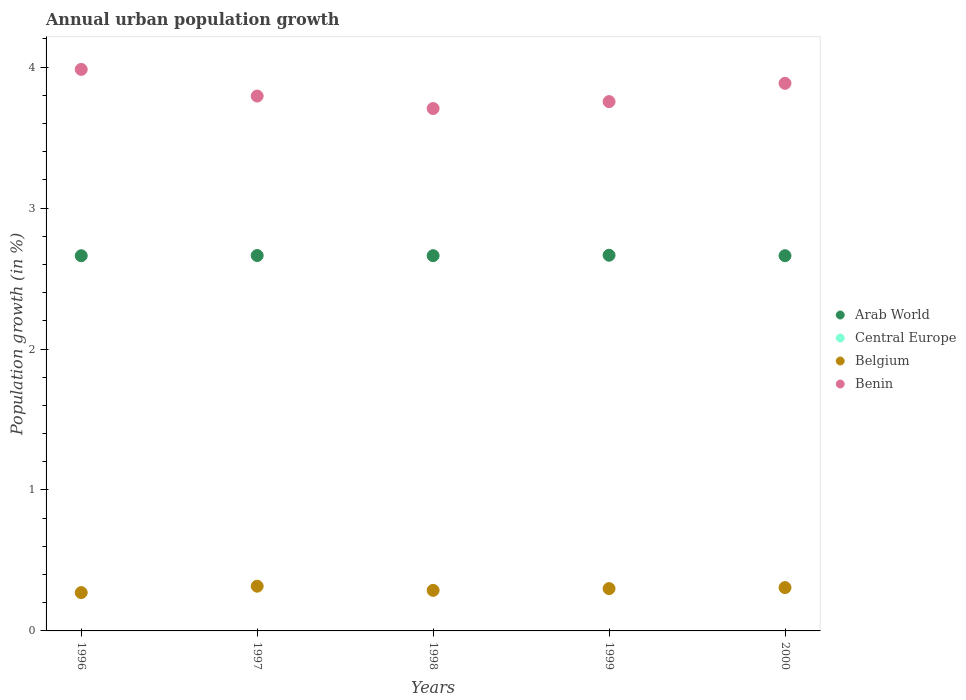Is the number of dotlines equal to the number of legend labels?
Your answer should be very brief. No. What is the percentage of urban population growth in Central Europe in 1999?
Offer a terse response. 0. Across all years, what is the maximum percentage of urban population growth in Arab World?
Your response must be concise. 2.67. What is the total percentage of urban population growth in Central Europe in the graph?
Keep it short and to the point. 0. What is the difference between the percentage of urban population growth in Benin in 1997 and that in 2000?
Give a very brief answer. -0.09. What is the difference between the percentage of urban population growth in Arab World in 1997 and the percentage of urban population growth in Belgium in 1996?
Ensure brevity in your answer.  2.39. In the year 1996, what is the difference between the percentage of urban population growth in Arab World and percentage of urban population growth in Benin?
Ensure brevity in your answer.  -1.32. In how many years, is the percentage of urban population growth in Central Europe greater than 2.8 %?
Keep it short and to the point. 0. What is the ratio of the percentage of urban population growth in Arab World in 1999 to that in 2000?
Your response must be concise. 1. Is the difference between the percentage of urban population growth in Arab World in 1996 and 1999 greater than the difference between the percentage of urban population growth in Benin in 1996 and 1999?
Offer a terse response. No. What is the difference between the highest and the second highest percentage of urban population growth in Benin?
Provide a short and direct response. 0.1. What is the difference between the highest and the lowest percentage of urban population growth in Arab World?
Make the answer very short. 0. In how many years, is the percentage of urban population growth in Arab World greater than the average percentage of urban population growth in Arab World taken over all years?
Give a very brief answer. 2. Is it the case that in every year, the sum of the percentage of urban population growth in Arab World and percentage of urban population growth in Benin  is greater than the sum of percentage of urban population growth in Central Europe and percentage of urban population growth in Belgium?
Your response must be concise. No. Does the percentage of urban population growth in Belgium monotonically increase over the years?
Make the answer very short. No. Is the percentage of urban population growth in Belgium strictly greater than the percentage of urban population growth in Arab World over the years?
Keep it short and to the point. No. Is the percentage of urban population growth in Belgium strictly less than the percentage of urban population growth in Arab World over the years?
Offer a very short reply. Yes. What is the difference between two consecutive major ticks on the Y-axis?
Provide a succinct answer. 1. Are the values on the major ticks of Y-axis written in scientific E-notation?
Your answer should be very brief. No. Does the graph contain any zero values?
Offer a very short reply. Yes. Does the graph contain grids?
Your answer should be compact. No. How many legend labels are there?
Offer a very short reply. 4. How are the legend labels stacked?
Offer a very short reply. Vertical. What is the title of the graph?
Give a very brief answer. Annual urban population growth. Does "Paraguay" appear as one of the legend labels in the graph?
Provide a succinct answer. No. What is the label or title of the Y-axis?
Offer a very short reply. Population growth (in %). What is the Population growth (in %) of Arab World in 1996?
Offer a very short reply. 2.66. What is the Population growth (in %) in Central Europe in 1996?
Make the answer very short. 0. What is the Population growth (in %) of Belgium in 1996?
Your response must be concise. 0.27. What is the Population growth (in %) of Benin in 1996?
Offer a terse response. 3.98. What is the Population growth (in %) in Arab World in 1997?
Provide a succinct answer. 2.66. What is the Population growth (in %) in Central Europe in 1997?
Provide a short and direct response. 0. What is the Population growth (in %) in Belgium in 1997?
Your answer should be compact. 0.32. What is the Population growth (in %) of Benin in 1997?
Your answer should be very brief. 3.79. What is the Population growth (in %) in Arab World in 1998?
Your response must be concise. 2.66. What is the Population growth (in %) in Central Europe in 1998?
Provide a short and direct response. 0. What is the Population growth (in %) in Belgium in 1998?
Offer a very short reply. 0.29. What is the Population growth (in %) of Benin in 1998?
Offer a terse response. 3.71. What is the Population growth (in %) in Arab World in 1999?
Your answer should be very brief. 2.67. What is the Population growth (in %) of Belgium in 1999?
Give a very brief answer. 0.3. What is the Population growth (in %) in Benin in 1999?
Provide a short and direct response. 3.76. What is the Population growth (in %) of Arab World in 2000?
Ensure brevity in your answer.  2.66. What is the Population growth (in %) in Central Europe in 2000?
Offer a very short reply. 0. What is the Population growth (in %) in Belgium in 2000?
Your answer should be compact. 0.31. What is the Population growth (in %) in Benin in 2000?
Provide a short and direct response. 3.88. Across all years, what is the maximum Population growth (in %) of Arab World?
Make the answer very short. 2.67. Across all years, what is the maximum Population growth (in %) of Belgium?
Provide a succinct answer. 0.32. Across all years, what is the maximum Population growth (in %) in Benin?
Keep it short and to the point. 3.98. Across all years, what is the minimum Population growth (in %) in Arab World?
Provide a short and direct response. 2.66. Across all years, what is the minimum Population growth (in %) of Belgium?
Offer a very short reply. 0.27. Across all years, what is the minimum Population growth (in %) in Benin?
Offer a terse response. 3.71. What is the total Population growth (in %) in Arab World in the graph?
Your answer should be compact. 13.31. What is the total Population growth (in %) in Belgium in the graph?
Ensure brevity in your answer.  1.48. What is the total Population growth (in %) of Benin in the graph?
Keep it short and to the point. 19.12. What is the difference between the Population growth (in %) in Arab World in 1996 and that in 1997?
Your answer should be compact. -0. What is the difference between the Population growth (in %) of Belgium in 1996 and that in 1997?
Offer a very short reply. -0.05. What is the difference between the Population growth (in %) of Benin in 1996 and that in 1997?
Make the answer very short. 0.19. What is the difference between the Population growth (in %) in Arab World in 1996 and that in 1998?
Ensure brevity in your answer.  -0. What is the difference between the Population growth (in %) of Belgium in 1996 and that in 1998?
Ensure brevity in your answer.  -0.02. What is the difference between the Population growth (in %) in Benin in 1996 and that in 1998?
Keep it short and to the point. 0.28. What is the difference between the Population growth (in %) in Arab World in 1996 and that in 1999?
Give a very brief answer. -0. What is the difference between the Population growth (in %) in Belgium in 1996 and that in 1999?
Offer a terse response. -0.03. What is the difference between the Population growth (in %) in Benin in 1996 and that in 1999?
Give a very brief answer. 0.23. What is the difference between the Population growth (in %) of Arab World in 1996 and that in 2000?
Make the answer very short. -0. What is the difference between the Population growth (in %) of Belgium in 1996 and that in 2000?
Provide a succinct answer. -0.04. What is the difference between the Population growth (in %) in Benin in 1996 and that in 2000?
Give a very brief answer. 0.1. What is the difference between the Population growth (in %) in Arab World in 1997 and that in 1998?
Offer a very short reply. 0. What is the difference between the Population growth (in %) in Belgium in 1997 and that in 1998?
Keep it short and to the point. 0.03. What is the difference between the Population growth (in %) in Benin in 1997 and that in 1998?
Provide a short and direct response. 0.09. What is the difference between the Population growth (in %) in Arab World in 1997 and that in 1999?
Offer a very short reply. -0. What is the difference between the Population growth (in %) of Belgium in 1997 and that in 1999?
Your response must be concise. 0.02. What is the difference between the Population growth (in %) in Benin in 1997 and that in 1999?
Offer a very short reply. 0.04. What is the difference between the Population growth (in %) of Arab World in 1997 and that in 2000?
Make the answer very short. 0. What is the difference between the Population growth (in %) in Belgium in 1997 and that in 2000?
Your answer should be very brief. 0.01. What is the difference between the Population growth (in %) in Benin in 1997 and that in 2000?
Make the answer very short. -0.09. What is the difference between the Population growth (in %) of Arab World in 1998 and that in 1999?
Make the answer very short. -0. What is the difference between the Population growth (in %) of Belgium in 1998 and that in 1999?
Ensure brevity in your answer.  -0.01. What is the difference between the Population growth (in %) in Benin in 1998 and that in 1999?
Your answer should be very brief. -0.05. What is the difference between the Population growth (in %) in Arab World in 1998 and that in 2000?
Your response must be concise. 0. What is the difference between the Population growth (in %) in Belgium in 1998 and that in 2000?
Your answer should be compact. -0.02. What is the difference between the Population growth (in %) in Benin in 1998 and that in 2000?
Offer a terse response. -0.18. What is the difference between the Population growth (in %) in Arab World in 1999 and that in 2000?
Keep it short and to the point. 0. What is the difference between the Population growth (in %) of Belgium in 1999 and that in 2000?
Your answer should be very brief. -0.01. What is the difference between the Population growth (in %) of Benin in 1999 and that in 2000?
Provide a succinct answer. -0.13. What is the difference between the Population growth (in %) in Arab World in 1996 and the Population growth (in %) in Belgium in 1997?
Make the answer very short. 2.34. What is the difference between the Population growth (in %) of Arab World in 1996 and the Population growth (in %) of Benin in 1997?
Make the answer very short. -1.13. What is the difference between the Population growth (in %) of Belgium in 1996 and the Population growth (in %) of Benin in 1997?
Make the answer very short. -3.52. What is the difference between the Population growth (in %) in Arab World in 1996 and the Population growth (in %) in Belgium in 1998?
Give a very brief answer. 2.37. What is the difference between the Population growth (in %) in Arab World in 1996 and the Population growth (in %) in Benin in 1998?
Offer a terse response. -1.04. What is the difference between the Population growth (in %) of Belgium in 1996 and the Population growth (in %) of Benin in 1998?
Ensure brevity in your answer.  -3.43. What is the difference between the Population growth (in %) of Arab World in 1996 and the Population growth (in %) of Belgium in 1999?
Keep it short and to the point. 2.36. What is the difference between the Population growth (in %) of Arab World in 1996 and the Population growth (in %) of Benin in 1999?
Your response must be concise. -1.09. What is the difference between the Population growth (in %) in Belgium in 1996 and the Population growth (in %) in Benin in 1999?
Provide a short and direct response. -3.48. What is the difference between the Population growth (in %) in Arab World in 1996 and the Population growth (in %) in Belgium in 2000?
Your answer should be very brief. 2.35. What is the difference between the Population growth (in %) in Arab World in 1996 and the Population growth (in %) in Benin in 2000?
Offer a terse response. -1.22. What is the difference between the Population growth (in %) of Belgium in 1996 and the Population growth (in %) of Benin in 2000?
Give a very brief answer. -3.61. What is the difference between the Population growth (in %) in Arab World in 1997 and the Population growth (in %) in Belgium in 1998?
Provide a succinct answer. 2.38. What is the difference between the Population growth (in %) in Arab World in 1997 and the Population growth (in %) in Benin in 1998?
Your answer should be very brief. -1.04. What is the difference between the Population growth (in %) of Belgium in 1997 and the Population growth (in %) of Benin in 1998?
Offer a very short reply. -3.39. What is the difference between the Population growth (in %) in Arab World in 1997 and the Population growth (in %) in Belgium in 1999?
Offer a terse response. 2.36. What is the difference between the Population growth (in %) of Arab World in 1997 and the Population growth (in %) of Benin in 1999?
Your answer should be compact. -1.09. What is the difference between the Population growth (in %) of Belgium in 1997 and the Population growth (in %) of Benin in 1999?
Your response must be concise. -3.44. What is the difference between the Population growth (in %) of Arab World in 1997 and the Population growth (in %) of Belgium in 2000?
Ensure brevity in your answer.  2.36. What is the difference between the Population growth (in %) of Arab World in 1997 and the Population growth (in %) of Benin in 2000?
Give a very brief answer. -1.22. What is the difference between the Population growth (in %) in Belgium in 1997 and the Population growth (in %) in Benin in 2000?
Give a very brief answer. -3.57. What is the difference between the Population growth (in %) in Arab World in 1998 and the Population growth (in %) in Belgium in 1999?
Keep it short and to the point. 2.36. What is the difference between the Population growth (in %) of Arab World in 1998 and the Population growth (in %) of Benin in 1999?
Keep it short and to the point. -1.09. What is the difference between the Population growth (in %) of Belgium in 1998 and the Population growth (in %) of Benin in 1999?
Offer a very short reply. -3.47. What is the difference between the Population growth (in %) of Arab World in 1998 and the Population growth (in %) of Belgium in 2000?
Provide a short and direct response. 2.35. What is the difference between the Population growth (in %) in Arab World in 1998 and the Population growth (in %) in Benin in 2000?
Make the answer very short. -1.22. What is the difference between the Population growth (in %) in Belgium in 1998 and the Population growth (in %) in Benin in 2000?
Offer a very short reply. -3.6. What is the difference between the Population growth (in %) of Arab World in 1999 and the Population growth (in %) of Belgium in 2000?
Ensure brevity in your answer.  2.36. What is the difference between the Population growth (in %) in Arab World in 1999 and the Population growth (in %) in Benin in 2000?
Keep it short and to the point. -1.22. What is the difference between the Population growth (in %) of Belgium in 1999 and the Population growth (in %) of Benin in 2000?
Your response must be concise. -3.58. What is the average Population growth (in %) in Arab World per year?
Your response must be concise. 2.66. What is the average Population growth (in %) of Central Europe per year?
Keep it short and to the point. 0. What is the average Population growth (in %) of Belgium per year?
Offer a terse response. 0.3. What is the average Population growth (in %) of Benin per year?
Offer a terse response. 3.82. In the year 1996, what is the difference between the Population growth (in %) in Arab World and Population growth (in %) in Belgium?
Your answer should be very brief. 2.39. In the year 1996, what is the difference between the Population growth (in %) of Arab World and Population growth (in %) of Benin?
Provide a short and direct response. -1.32. In the year 1996, what is the difference between the Population growth (in %) of Belgium and Population growth (in %) of Benin?
Offer a very short reply. -3.71. In the year 1997, what is the difference between the Population growth (in %) of Arab World and Population growth (in %) of Belgium?
Give a very brief answer. 2.35. In the year 1997, what is the difference between the Population growth (in %) of Arab World and Population growth (in %) of Benin?
Your answer should be compact. -1.13. In the year 1997, what is the difference between the Population growth (in %) in Belgium and Population growth (in %) in Benin?
Ensure brevity in your answer.  -3.48. In the year 1998, what is the difference between the Population growth (in %) in Arab World and Population growth (in %) in Belgium?
Your answer should be very brief. 2.37. In the year 1998, what is the difference between the Population growth (in %) of Arab World and Population growth (in %) of Benin?
Give a very brief answer. -1.04. In the year 1998, what is the difference between the Population growth (in %) of Belgium and Population growth (in %) of Benin?
Your response must be concise. -3.42. In the year 1999, what is the difference between the Population growth (in %) of Arab World and Population growth (in %) of Belgium?
Offer a very short reply. 2.37. In the year 1999, what is the difference between the Population growth (in %) of Arab World and Population growth (in %) of Benin?
Give a very brief answer. -1.09. In the year 1999, what is the difference between the Population growth (in %) of Belgium and Population growth (in %) of Benin?
Provide a short and direct response. -3.45. In the year 2000, what is the difference between the Population growth (in %) in Arab World and Population growth (in %) in Belgium?
Make the answer very short. 2.35. In the year 2000, what is the difference between the Population growth (in %) of Arab World and Population growth (in %) of Benin?
Your answer should be compact. -1.22. In the year 2000, what is the difference between the Population growth (in %) of Belgium and Population growth (in %) of Benin?
Offer a terse response. -3.58. What is the ratio of the Population growth (in %) in Belgium in 1996 to that in 1997?
Your response must be concise. 0.86. What is the ratio of the Population growth (in %) of Benin in 1996 to that in 1997?
Offer a very short reply. 1.05. What is the ratio of the Population growth (in %) in Belgium in 1996 to that in 1998?
Your response must be concise. 0.94. What is the ratio of the Population growth (in %) of Benin in 1996 to that in 1998?
Ensure brevity in your answer.  1.07. What is the ratio of the Population growth (in %) of Belgium in 1996 to that in 1999?
Provide a succinct answer. 0.91. What is the ratio of the Population growth (in %) in Benin in 1996 to that in 1999?
Give a very brief answer. 1.06. What is the ratio of the Population growth (in %) of Arab World in 1996 to that in 2000?
Give a very brief answer. 1. What is the ratio of the Population growth (in %) in Belgium in 1996 to that in 2000?
Provide a short and direct response. 0.88. What is the ratio of the Population growth (in %) in Benin in 1996 to that in 2000?
Keep it short and to the point. 1.03. What is the ratio of the Population growth (in %) of Belgium in 1997 to that in 1998?
Provide a short and direct response. 1.1. What is the ratio of the Population growth (in %) of Benin in 1997 to that in 1998?
Make the answer very short. 1.02. What is the ratio of the Population growth (in %) of Belgium in 1997 to that in 1999?
Give a very brief answer. 1.06. What is the ratio of the Population growth (in %) in Benin in 1997 to that in 1999?
Provide a short and direct response. 1.01. What is the ratio of the Population growth (in %) in Arab World in 1997 to that in 2000?
Keep it short and to the point. 1. What is the ratio of the Population growth (in %) of Belgium in 1997 to that in 2000?
Keep it short and to the point. 1.03. What is the ratio of the Population growth (in %) in Benin in 1997 to that in 2000?
Ensure brevity in your answer.  0.98. What is the ratio of the Population growth (in %) of Arab World in 1998 to that in 1999?
Provide a short and direct response. 1. What is the ratio of the Population growth (in %) in Benin in 1998 to that in 1999?
Offer a terse response. 0.99. What is the ratio of the Population growth (in %) of Belgium in 1998 to that in 2000?
Keep it short and to the point. 0.94. What is the ratio of the Population growth (in %) of Benin in 1998 to that in 2000?
Your response must be concise. 0.95. What is the ratio of the Population growth (in %) in Belgium in 1999 to that in 2000?
Give a very brief answer. 0.98. What is the ratio of the Population growth (in %) in Benin in 1999 to that in 2000?
Ensure brevity in your answer.  0.97. What is the difference between the highest and the second highest Population growth (in %) in Arab World?
Ensure brevity in your answer.  0. What is the difference between the highest and the second highest Population growth (in %) in Belgium?
Provide a succinct answer. 0.01. What is the difference between the highest and the second highest Population growth (in %) in Benin?
Make the answer very short. 0.1. What is the difference between the highest and the lowest Population growth (in %) of Arab World?
Give a very brief answer. 0. What is the difference between the highest and the lowest Population growth (in %) of Belgium?
Offer a very short reply. 0.05. What is the difference between the highest and the lowest Population growth (in %) of Benin?
Offer a very short reply. 0.28. 